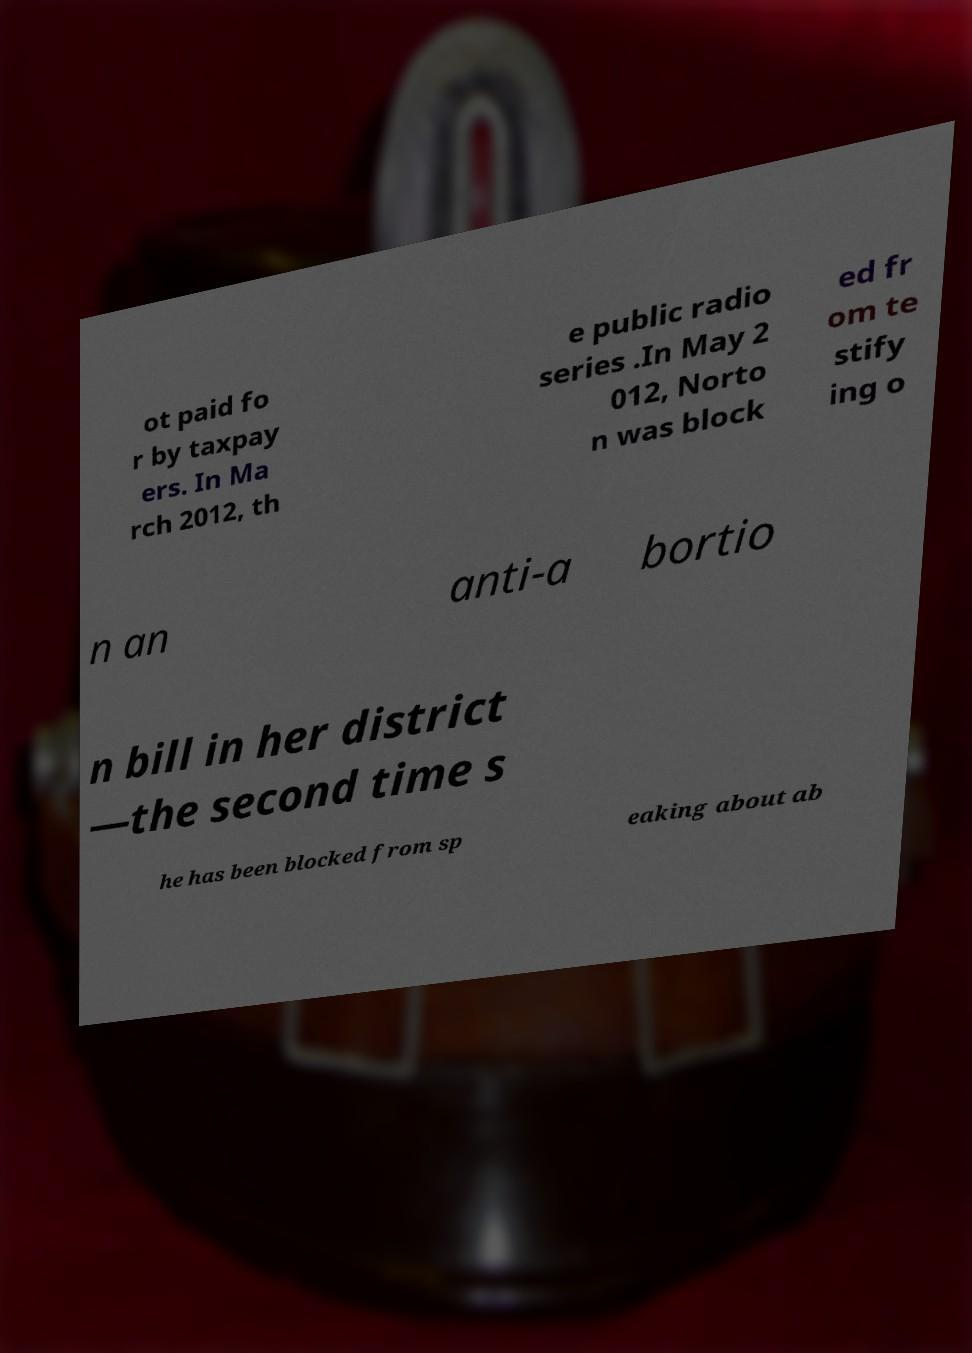Please read and relay the text visible in this image. What does it say? ot paid fo r by taxpay ers. In Ma rch 2012, th e public radio series .In May 2 012, Norto n was block ed fr om te stify ing o n an anti-a bortio n bill in her district —the second time s he has been blocked from sp eaking about ab 